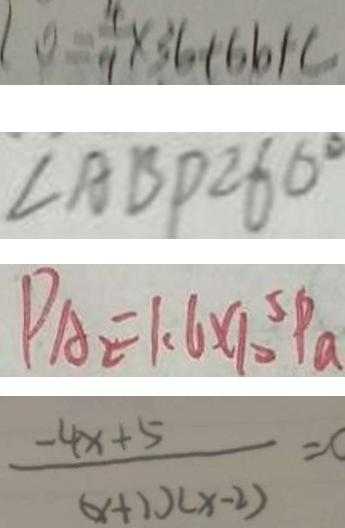<formula> <loc_0><loc_0><loc_500><loc_500>1 0 = \frac { 4 } { 9 } \times 3 6 + 6 6 + c 
 \angle A B D = 6 0 ^ { \circ } 
 P A _ { 2 } = 1 . 6 \times 1 0 ^ { 5 } P _ { a } 
 \frac { - 4 x + 5 } { ( x + 1 ) ( x - 2 ) } = c</formula> 